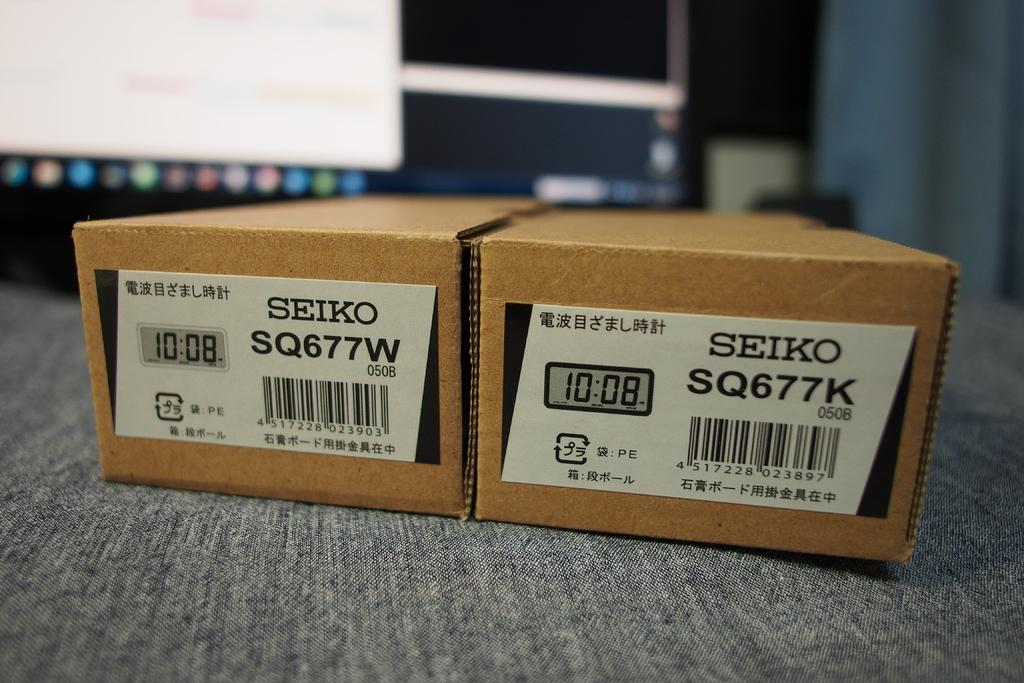Provide a one-sentence caption for the provided image. two boxes played in front of the computer screen which has a writings of SEIKO SQ677W and SQ677K. 